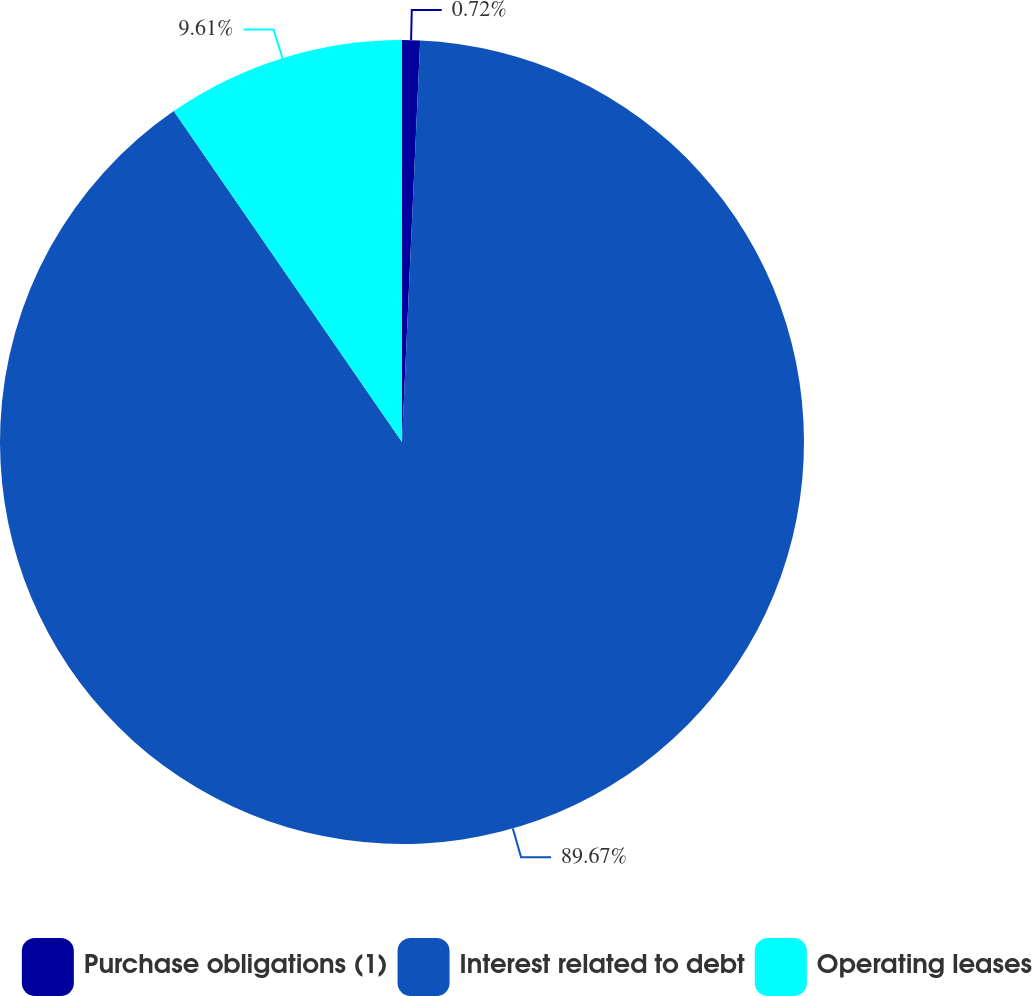Convert chart. <chart><loc_0><loc_0><loc_500><loc_500><pie_chart><fcel>Purchase obligations (1)<fcel>Interest related to debt<fcel>Operating leases<nl><fcel>0.72%<fcel>89.67%<fcel>9.61%<nl></chart> 